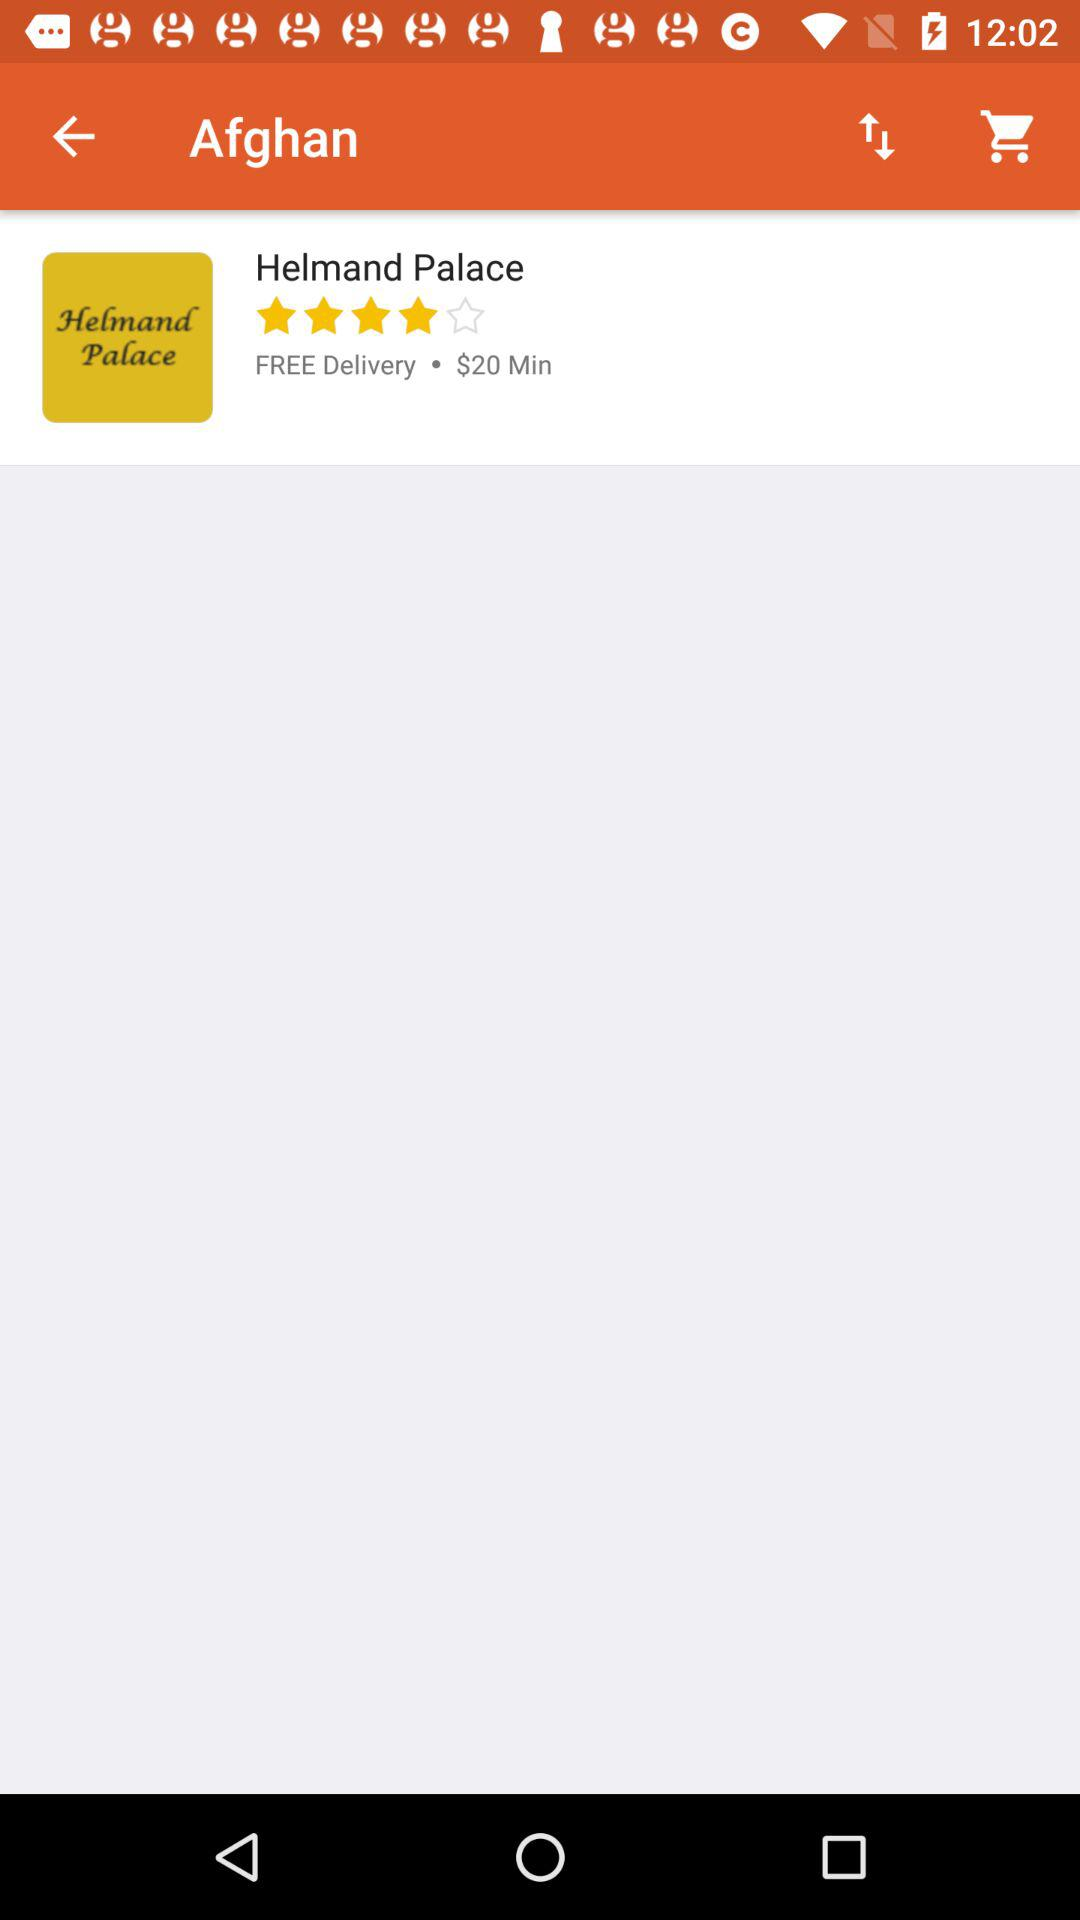How many minimum prices is helmand palace?
When the provided information is insufficient, respond with <no answer>. <no answer> 